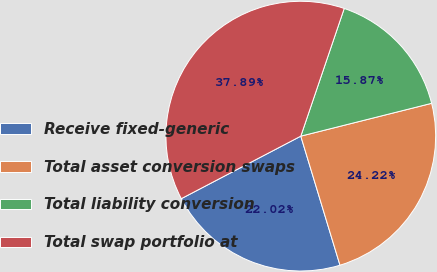Convert chart. <chart><loc_0><loc_0><loc_500><loc_500><pie_chart><fcel>Receive fixed-generic<fcel>Total asset conversion swaps<fcel>Total liability conversion<fcel>Total swap portfolio at<nl><fcel>22.02%<fcel>24.22%<fcel>15.87%<fcel>37.89%<nl></chart> 